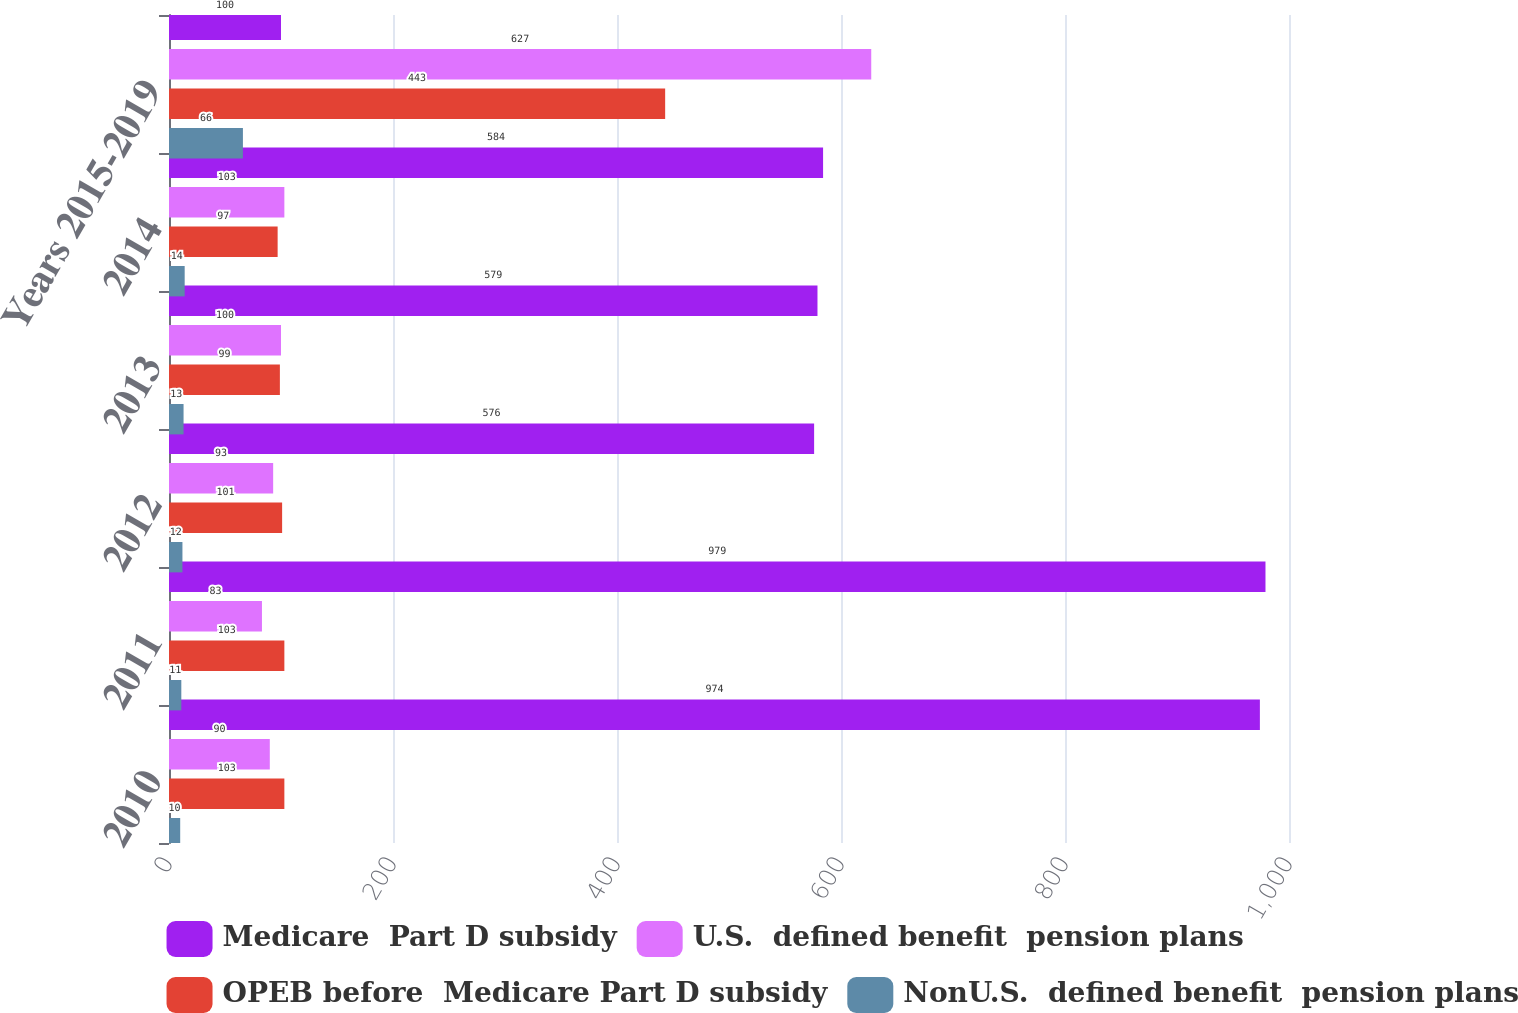Convert chart. <chart><loc_0><loc_0><loc_500><loc_500><stacked_bar_chart><ecel><fcel>2010<fcel>2011<fcel>2012<fcel>2013<fcel>2014<fcel>Years 2015-2019<nl><fcel>Medicare  Part D subsidy<fcel>974<fcel>979<fcel>576<fcel>579<fcel>584<fcel>100<nl><fcel>U.S.  defined benefit  pension plans<fcel>90<fcel>83<fcel>93<fcel>100<fcel>103<fcel>627<nl><fcel>OPEB before  Medicare Part D subsidy<fcel>103<fcel>103<fcel>101<fcel>99<fcel>97<fcel>443<nl><fcel>NonU.S.  defined benefit  pension plans<fcel>10<fcel>11<fcel>12<fcel>13<fcel>14<fcel>66<nl></chart> 